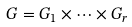Convert formula to latex. <formula><loc_0><loc_0><loc_500><loc_500>G = G _ { 1 } \times \dots \times G _ { r }</formula> 